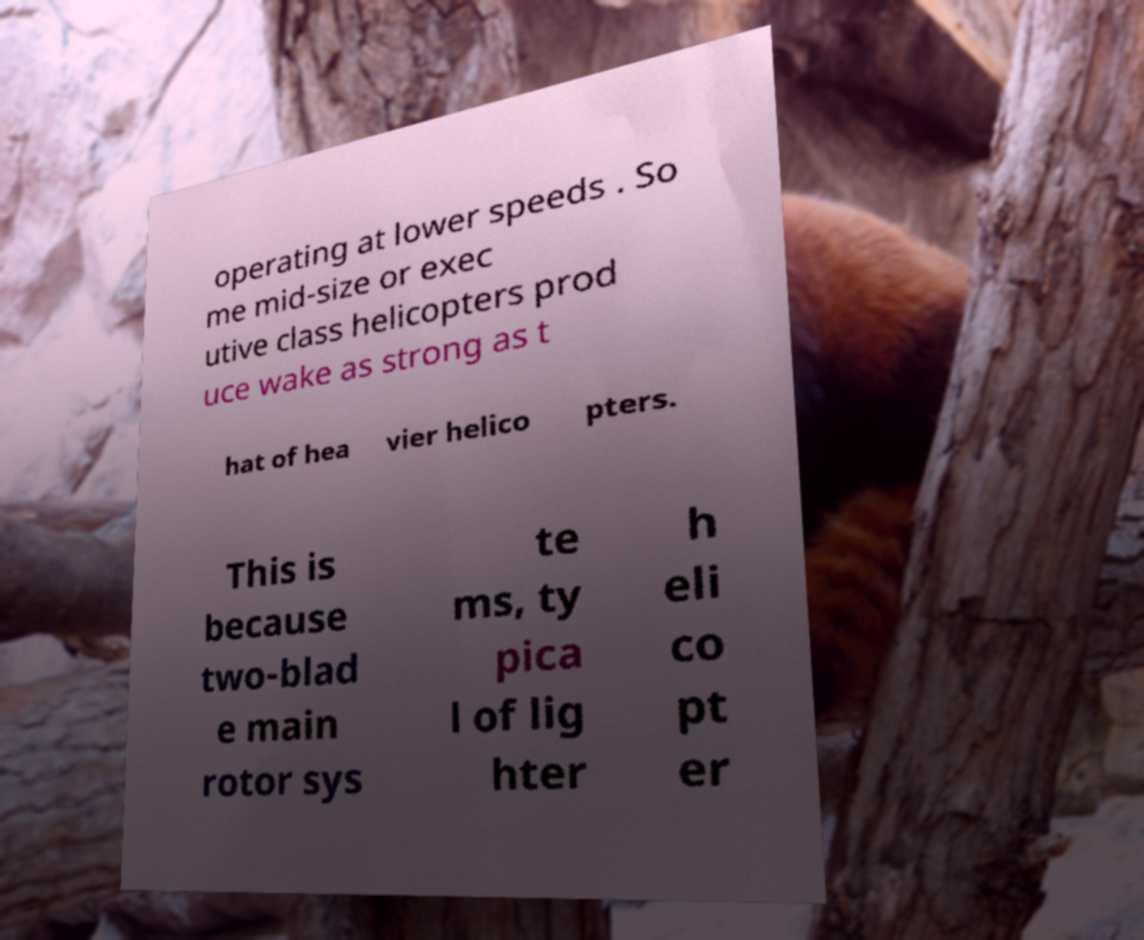Can you read and provide the text displayed in the image?This photo seems to have some interesting text. Can you extract and type it out for me? operating at lower speeds . So me mid-size or exec utive class helicopters prod uce wake as strong as t hat of hea vier helico pters. This is because two-blad e main rotor sys te ms, ty pica l of lig hter h eli co pt er 